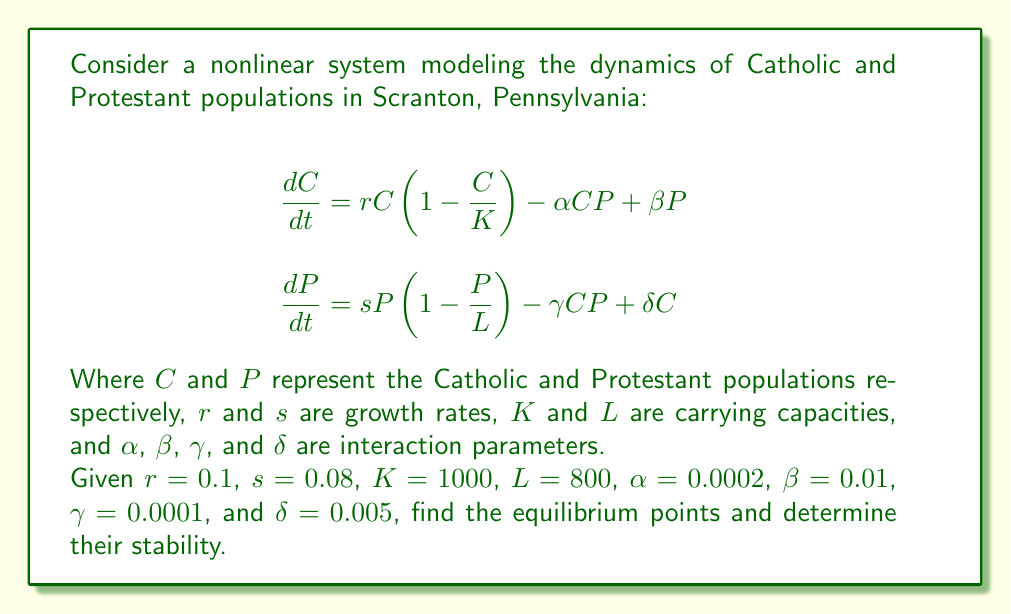Provide a solution to this math problem. To solve this problem, we'll follow these steps:

1) Find the equilibrium points by setting $\frac{dC}{dt} = 0$ and $\frac{dP}{dt} = 0$.

2) Solve the resulting system of equations.

3) Analyze the stability of each equilibrium point using the Jacobian matrix.

Step 1: Setting $\frac{dC}{dt} = 0$ and $\frac{dP}{dt} = 0$:

$$\begin{align}
0 &= 0.1C(1-\frac{C}{1000}) - 0.0002CP + 0.01P \\
0 &= 0.08P(1-\frac{P}{800}) - 0.0001CP + 0.005C
\end{align}$$

Step 2: Solving the system:

The trivial equilibrium point is $(C,P) = (0,0)$.

For non-trivial equilibrium points, we can use numerical methods. Using a computer algebra system, we find two additional equilibrium points:

$(C,P) \approx (1000, 0)$ and $(C,P) \approx (891.7, 718.3)$

Step 3: Stability analysis:

The Jacobian matrix is:

$$J = \begin{bmatrix}
0.1 - 0.0002C - 0.0002P & 0.01 - 0.0002C \\
0.005 - 0.0001P & 0.08 - 0.0002P - 0.0001C
\end{bmatrix}$$

For $(0,0)$:
$$J_{(0,0)} = \begin{bmatrix}
0.1 & 0.01 \\
0.005 & 0.08
\end{bmatrix}$$

Both eigenvalues are positive, so $(0,0)$ is an unstable node.

For $(1000,0)$:
$$J_{(1000,0)} = \begin{bmatrix}
-0.1 & -0.19 \\
0.005 & -0.02
\end{bmatrix}$$

The eigenvalues are approximately -0.1015 and -0.0185, both negative. This point is a stable node.

For $(891.7, 718.3)$:
$$J_{(891.7,718.3)} \approx \begin{bmatrix}
-0.0715 & -0.1683 \\
-0.0668 & -0.0632
\end{bmatrix}$$

The eigenvalues are approximately -0.0064 and -0.1283, both negative. This point is also a stable node.
Answer: Three equilibrium points: $(0,0)$ unstable, $(1000,0)$ stable, $(891.7,718.3)$ stable. 